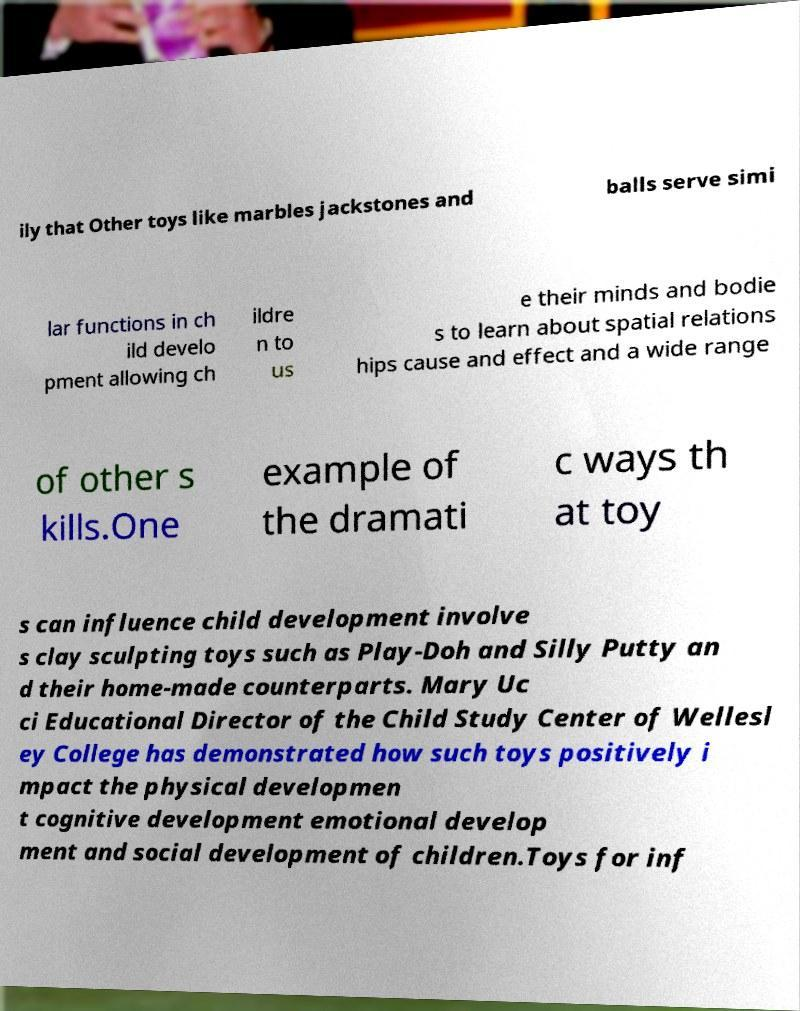What messages or text are displayed in this image? I need them in a readable, typed format. ily that Other toys like marbles jackstones and balls serve simi lar functions in ch ild develo pment allowing ch ildre n to us e their minds and bodie s to learn about spatial relations hips cause and effect and a wide range of other s kills.One example of the dramati c ways th at toy s can influence child development involve s clay sculpting toys such as Play-Doh and Silly Putty an d their home-made counterparts. Mary Uc ci Educational Director of the Child Study Center of Wellesl ey College has demonstrated how such toys positively i mpact the physical developmen t cognitive development emotional develop ment and social development of children.Toys for inf 